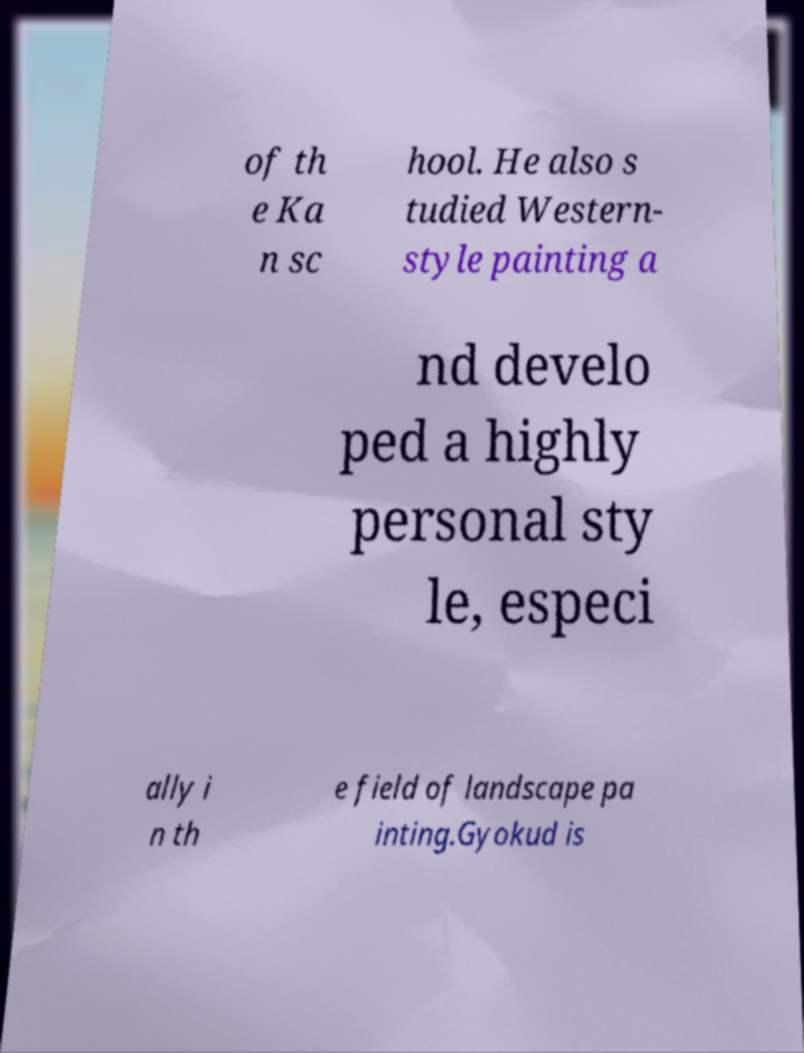Can you read and provide the text displayed in the image?This photo seems to have some interesting text. Can you extract and type it out for me? of th e Ka n sc hool. He also s tudied Western- style painting a nd develo ped a highly personal sty le, especi ally i n th e field of landscape pa inting.Gyokud is 